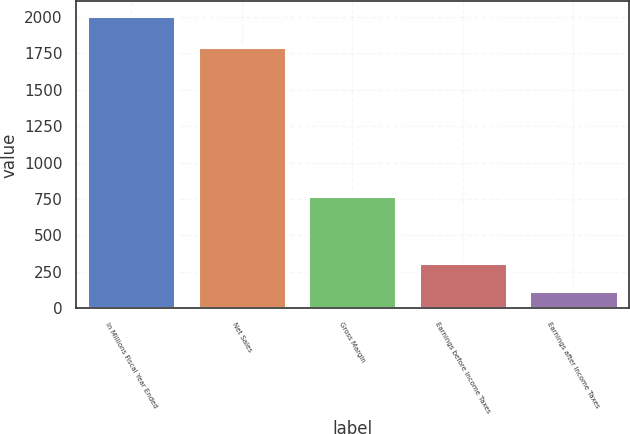Convert chart. <chart><loc_0><loc_0><loc_500><loc_500><bar_chart><fcel>In Millions Fiscal Year Ended<fcel>Net Sales<fcel>Gross Margin<fcel>Earnings before Income Taxes<fcel>Earnings after Income Taxes<nl><fcel>2006<fcel>1796<fcel>770<fcel>308.6<fcel>120<nl></chart> 